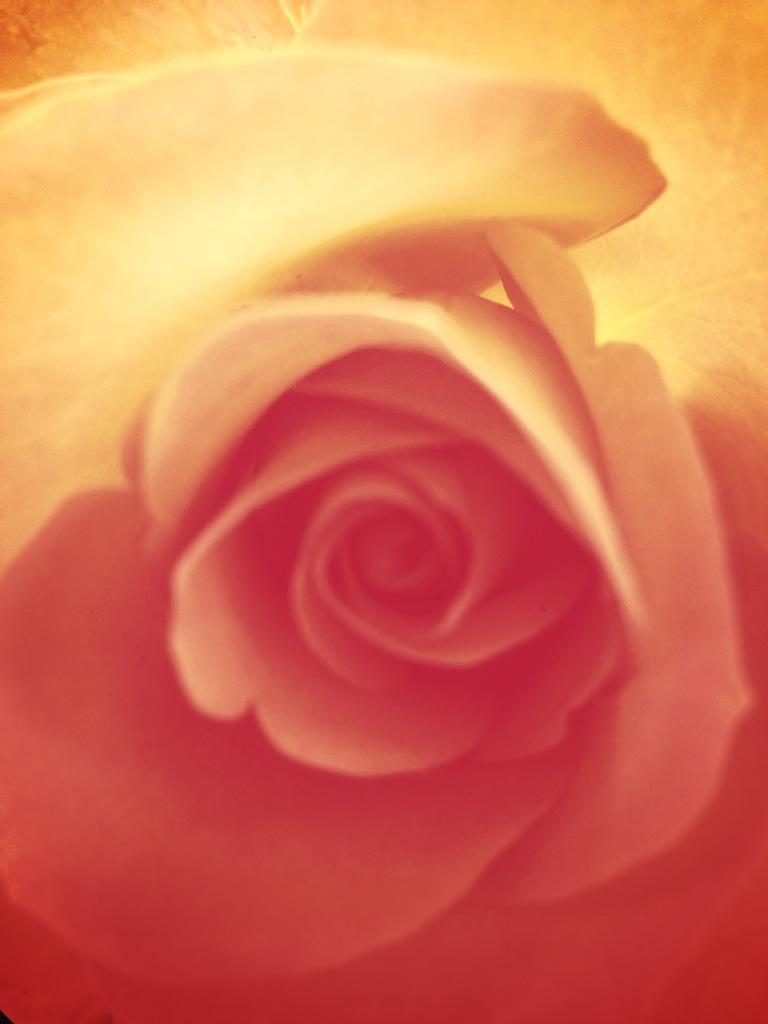What is the main subject of the image? The main subject of the image is a flower. How many colors are present in the flower's petals? The flower has petals in two colors. What color are the top petals of the flower? The top petals of the flower are white. What color are the bottom petals of the flower? The bottom petals of the flower are red. What type of club can be seen in the image? There is no club present in the image; it features a flower with petals in two colors. Can you tell me how many feet are visible in the image? There are no feet visible in the image; it features a flower with petals in two colors. 